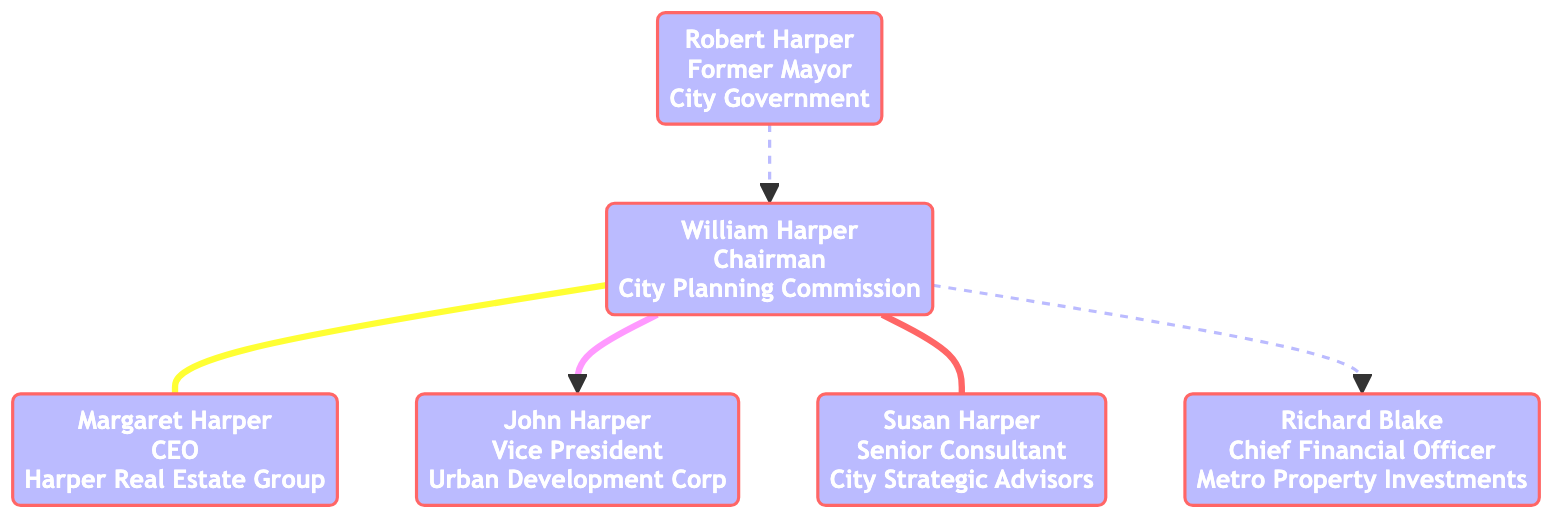What's the position of William Harper? William Harper is labeled as "Chairman" in the diagram.
Answer: Chairman How many children does William Harper have? The diagram shows that William Harper has one child, identified as John Harper.
Answer: 1 What is the relationship between William Harper and Margaret Harper? The diagram indicates that they are siblings, as denoted by the "sibling" connection.
Answer: Sibling Who is the spouse of William Harper? The spouse of William Harper is indicated as Susan Harper, who is connected with a "spouse" relationship.
Answer: Susan Harper What organization does John Harper work for? The diagram identifies John Harper's organization as "Urban Development Corp."
Answer: Urban Development Corp How is Richard Blake related to William Harper? The diagram indicates that Richard Blake is William Harper's cousin, connected with a "cousin" relationship.
Answer: Cousin Who is Robert Harper in relation to William Harper? Robert Harper is labeled as William Harper's uncle, connected with an "uncle" relationship in the diagram.
Answer: Uncle What position does Susan Harper hold? The diagram shows that Susan Harper is a "Senior Consultant" as per her label.
Answer: Senior Consultant How many total family members are represented in the diagram related to William Harper? Counting all individuals directly connected, there are five family members including William Harper himself.
Answer: 5 